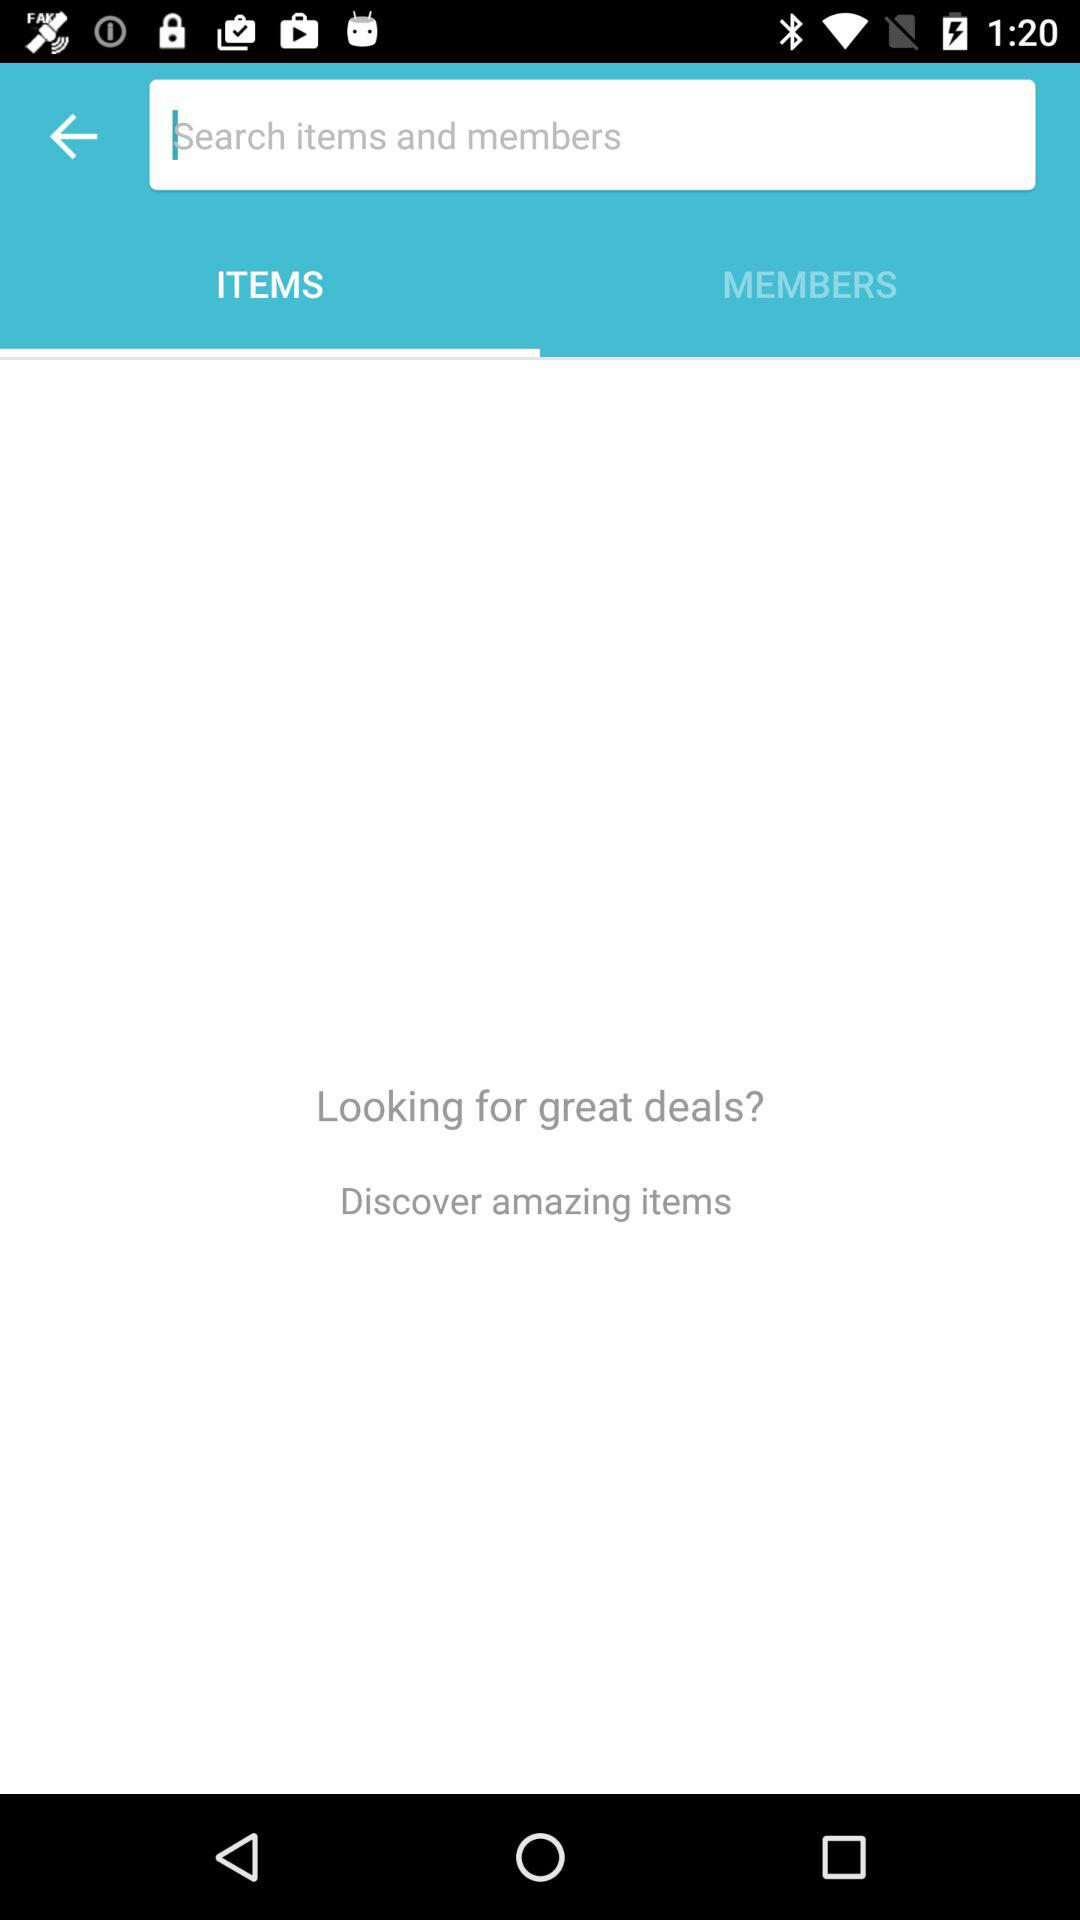Which option is selected? The selected option is "ITEMS". 